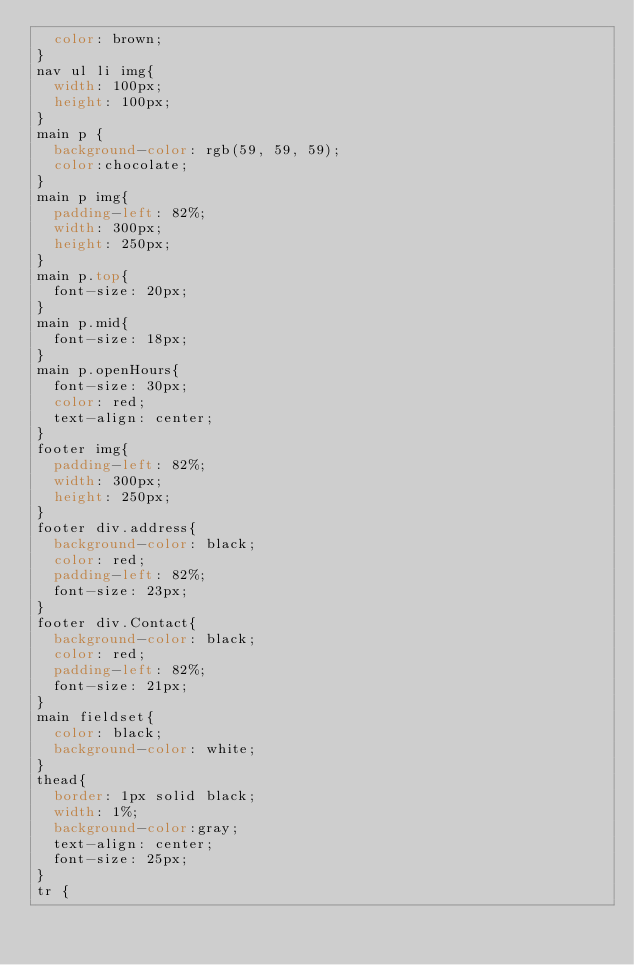<code> <loc_0><loc_0><loc_500><loc_500><_CSS_>  color: brown;
}
nav ul li img{
  width: 100px;
  height: 100px;
}
main p {
  background-color: rgb(59, 59, 59);
  color:chocolate;
}
main p img{
  padding-left: 82%;
  width: 300px;
  height: 250px;
}
main p.top{
  font-size: 20px;
}
main p.mid{
  font-size: 18px;
}
main p.openHours{
  font-size: 30px;
  color: red;
  text-align: center;
}
footer img{
  padding-left: 82%;
  width: 300px;
  height: 250px;
}
footer div.address{
  background-color: black;
  color: red;
  padding-left: 82%;
  font-size: 23px;
}
footer div.Contact{
  background-color: black;
  color: red;
  padding-left: 82%;
  font-size: 21px;
}
main fieldset{
  color: black;
  background-color: white;
}
thead{
  border: 1px solid black;
  width: 1%;
  background-color:gray;
  text-align: center;
  font-size: 25px;
}
tr {</code> 